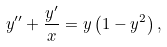Convert formula to latex. <formula><loc_0><loc_0><loc_500><loc_500>y ^ { \prime \prime } + \frac { y ^ { \prime } } { x } = y \left ( 1 - y ^ { 2 } \right ) ,</formula> 